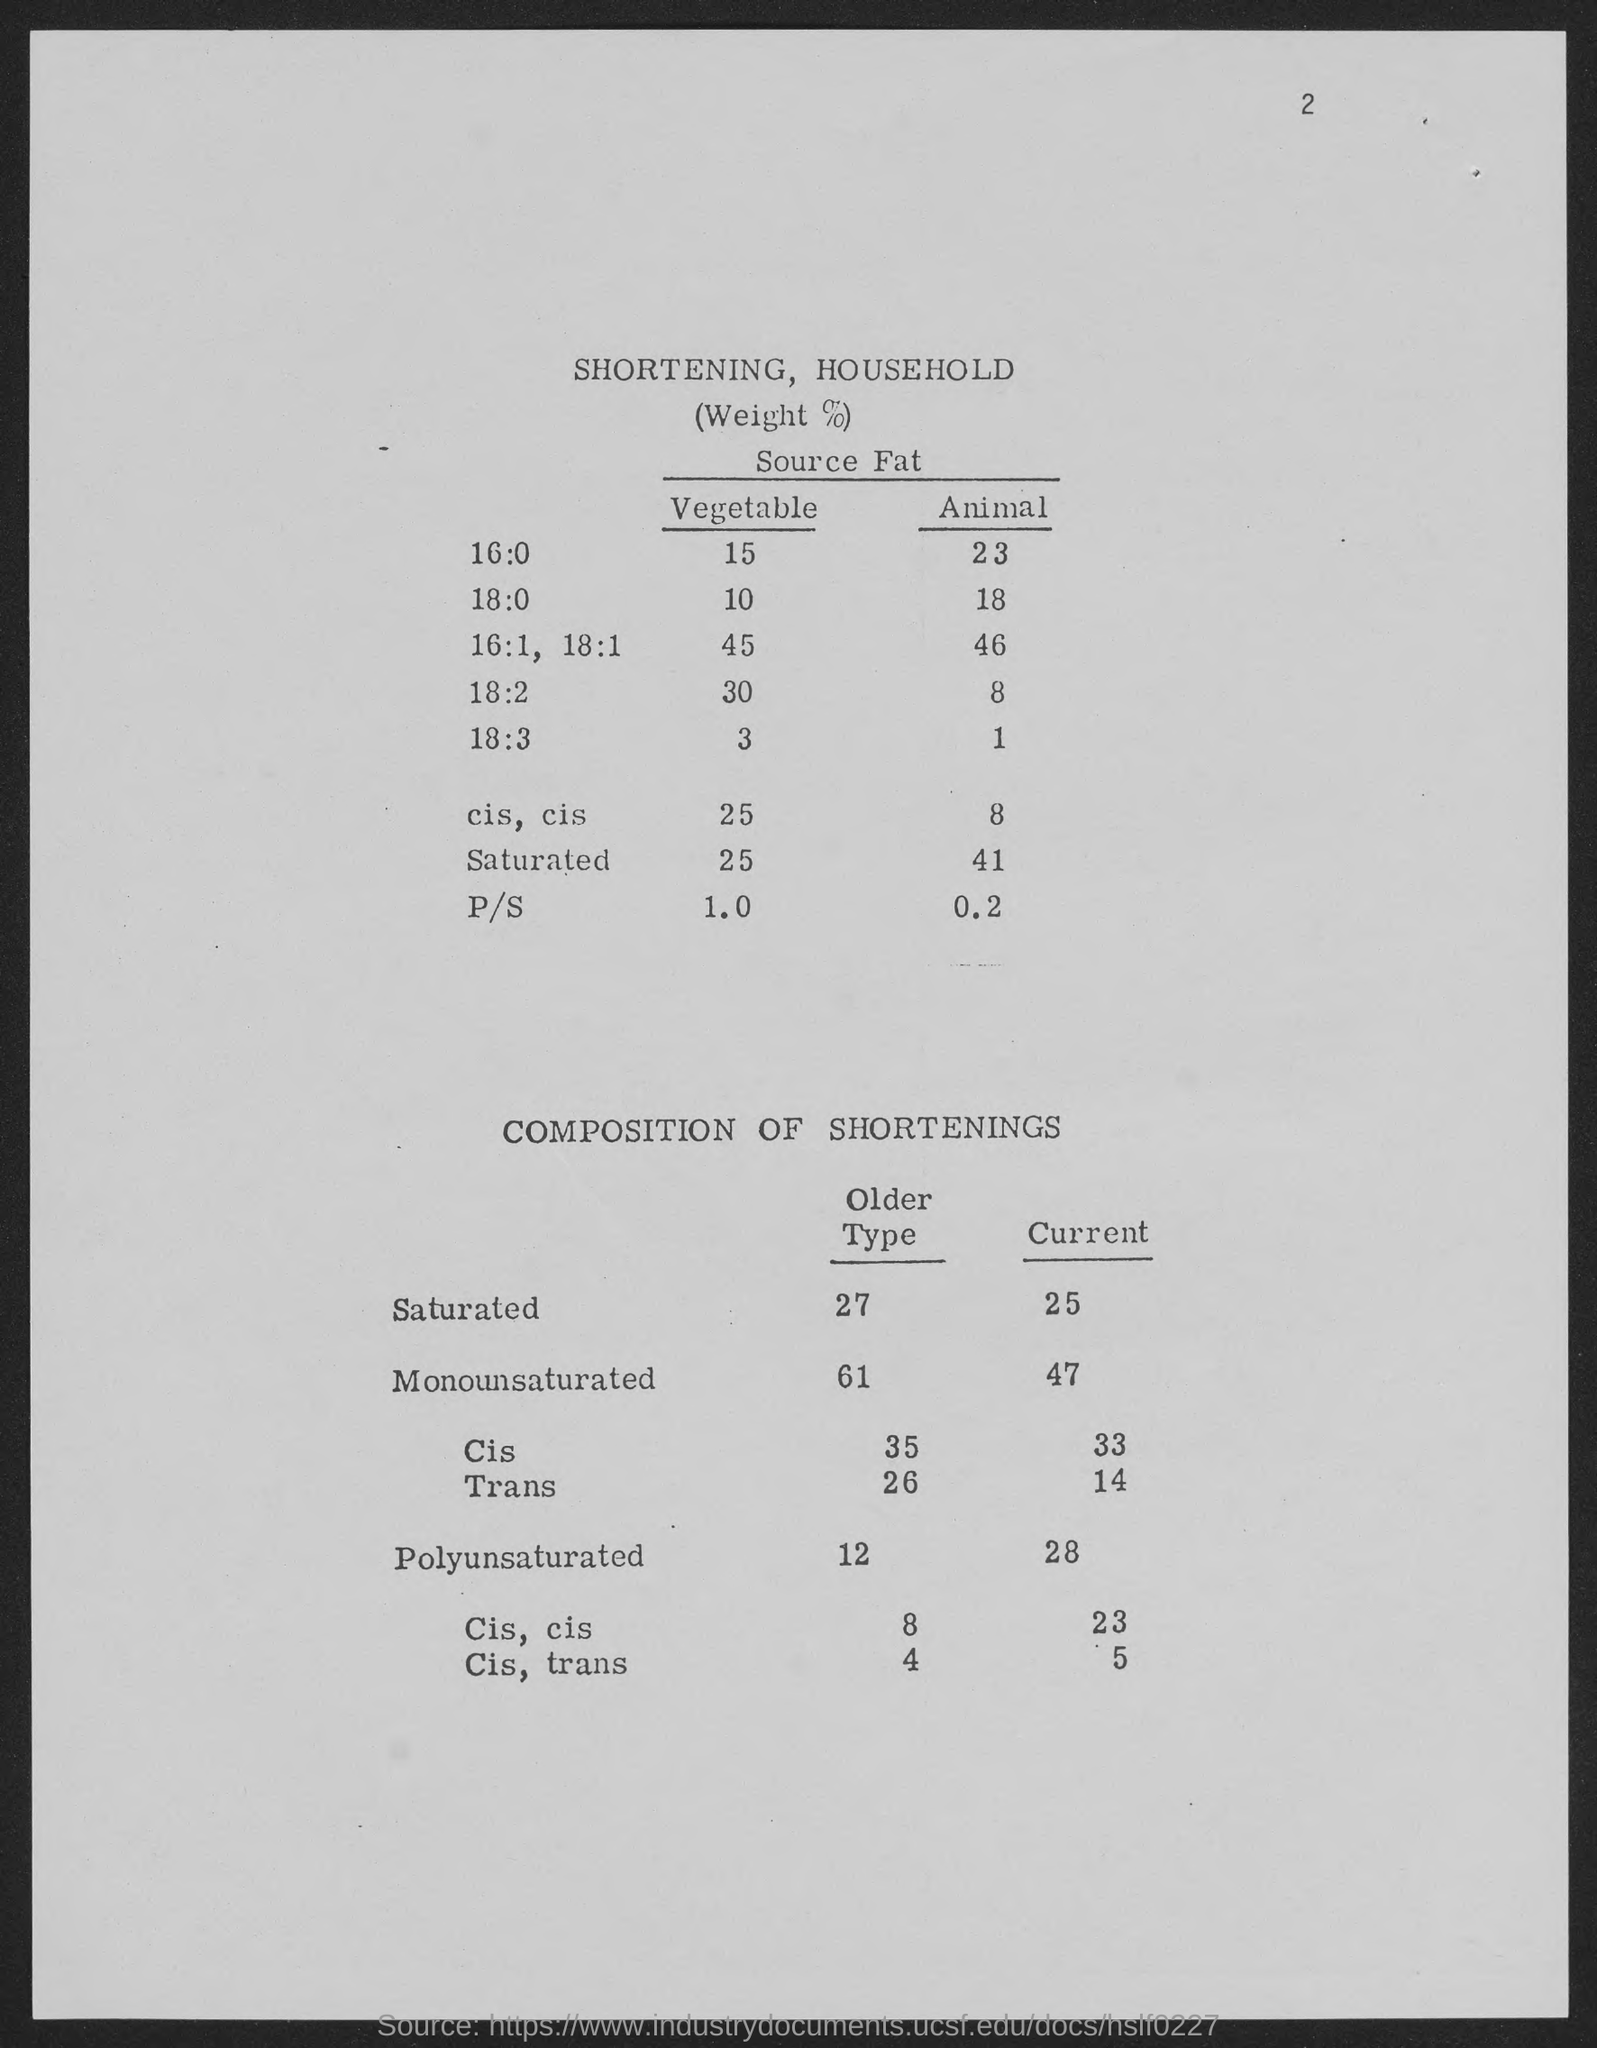Specify some key components in this picture. Saturated fats are a type of fat that are solid at room temperature. The older the saturated fat, the more solid it is. The number in the top-right corner of the page is 2. 